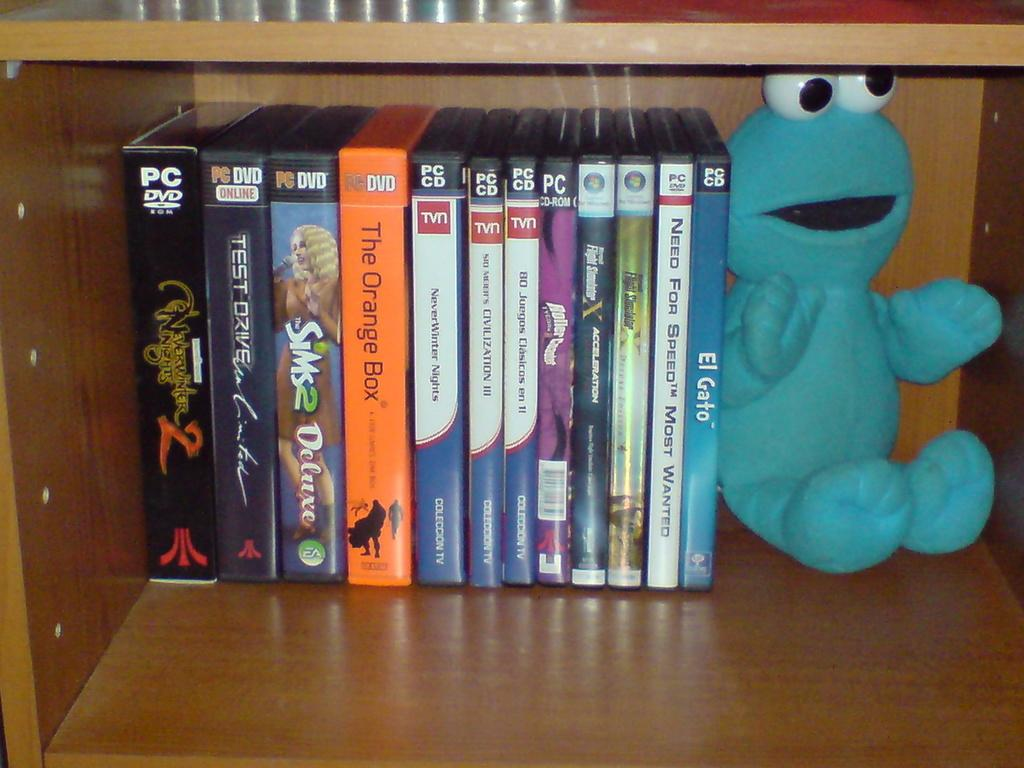<image>
Summarize the visual content of the image. A row of DVDs and CDs  such as El Gato next to a cookie monster doll. 